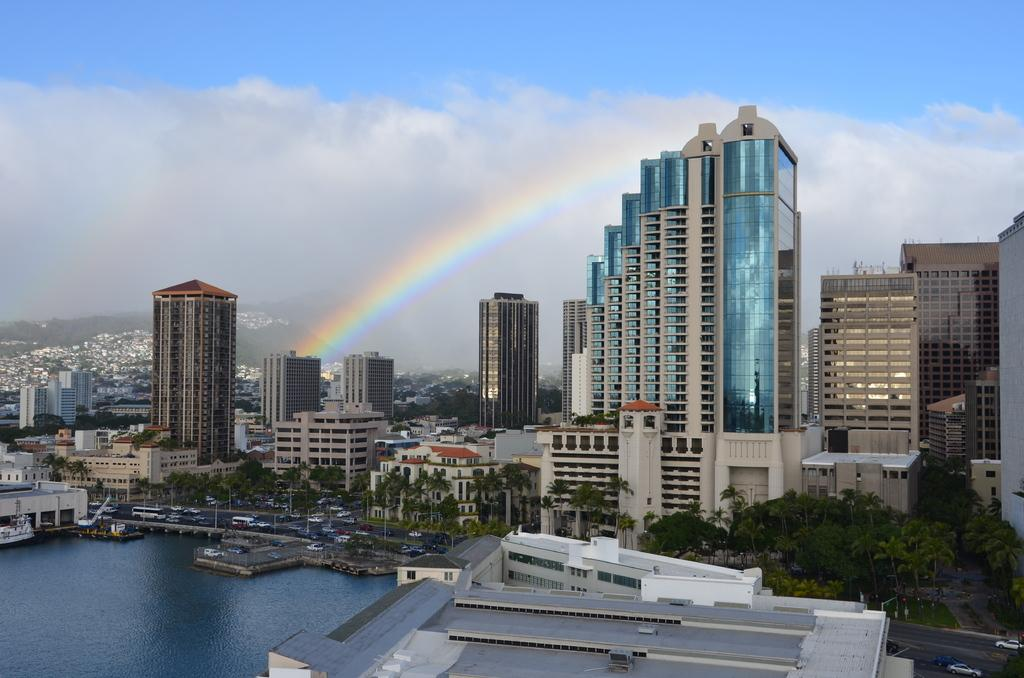What type of structures are visible in the image? There are buildings with windows in the image. What natural elements can be seen in the image? There are trees in the image. What man-made structure is present in the image? There is a bridge in the image. What mode of transportation is visible in the image? There are boats and vehicles in the image. What natural phenomenon is present in the image? There is a rainbow in the image. What is visible in the sky in the image? The sky with clouds is visible in the image. What type of knee can be seen supporting the bridge in the image? There is no knee present in the image; the bridge is supported by its structure. What type of fan is visible in the image? There is no fan present in the image. 